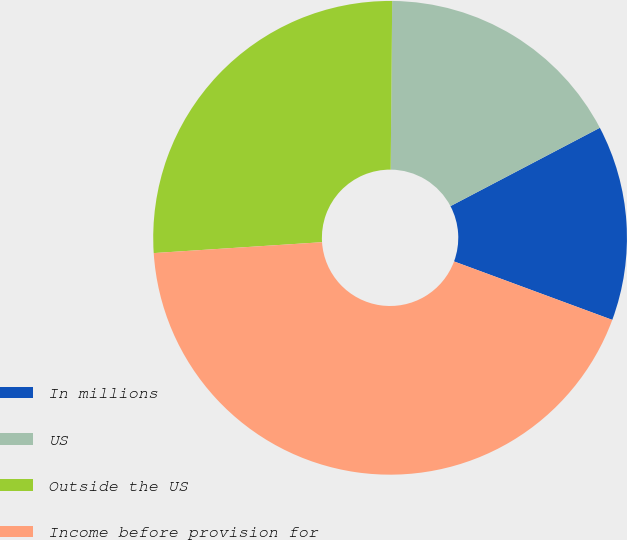Convert chart to OTSL. <chart><loc_0><loc_0><loc_500><loc_500><pie_chart><fcel>In millions<fcel>US<fcel>Outside the US<fcel>Income before provision for<nl><fcel>13.32%<fcel>17.17%<fcel>26.17%<fcel>43.34%<nl></chart> 